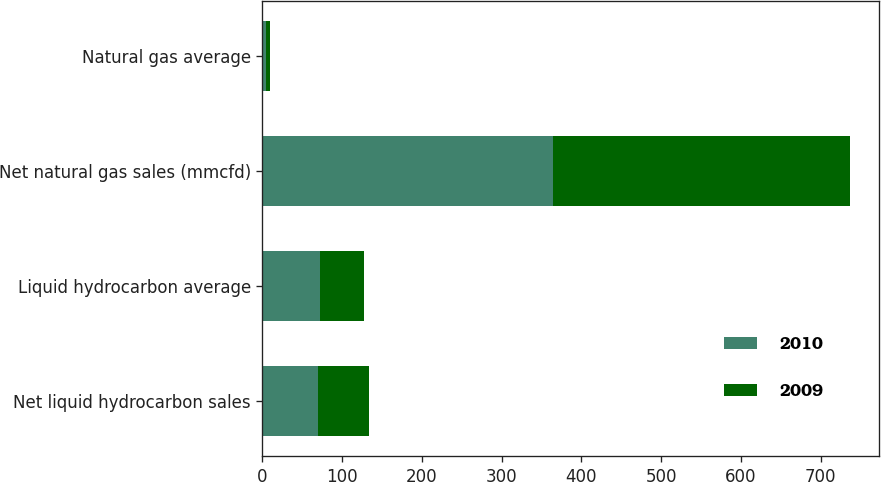<chart> <loc_0><loc_0><loc_500><loc_500><stacked_bar_chart><ecel><fcel>Net liquid hydrocarbon sales<fcel>Liquid hydrocarbon average<fcel>Net natural gas sales (mmcfd)<fcel>Natural gas average<nl><fcel>2010<fcel>70<fcel>72.3<fcel>364<fcel>4.71<nl><fcel>2009<fcel>64<fcel>54.67<fcel>373<fcel>4.14<nl></chart> 